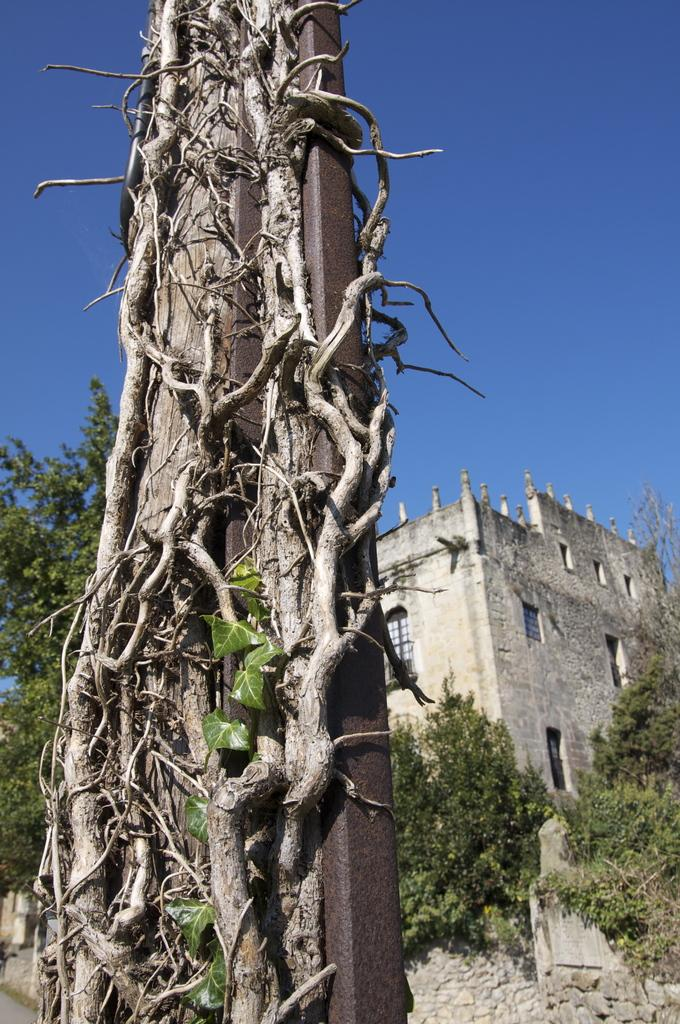What type of objects can be seen in the image? There are metal rods in the image. What type of vegetation is present in the image? Creepers, plants, and trees are visible in the image. What type of structure is in the image? There is a building in the image. What architectural feature can be seen on the building? Windows are present in the image. What part of the natural environment is visible in the image? The sky is visible in the image. Based on the visibility of the sky and the presence of shadows, when do you think the image was taken? The image was likely taken during the day. How many men are holding rifles in the image? There are no men or rifles present in the image. What type of crowd can be seen gathering around the trees in the image? There is no crowd present in the image; it only features metal rods, creepers, plants, trees, a building, windows, and the sky. 